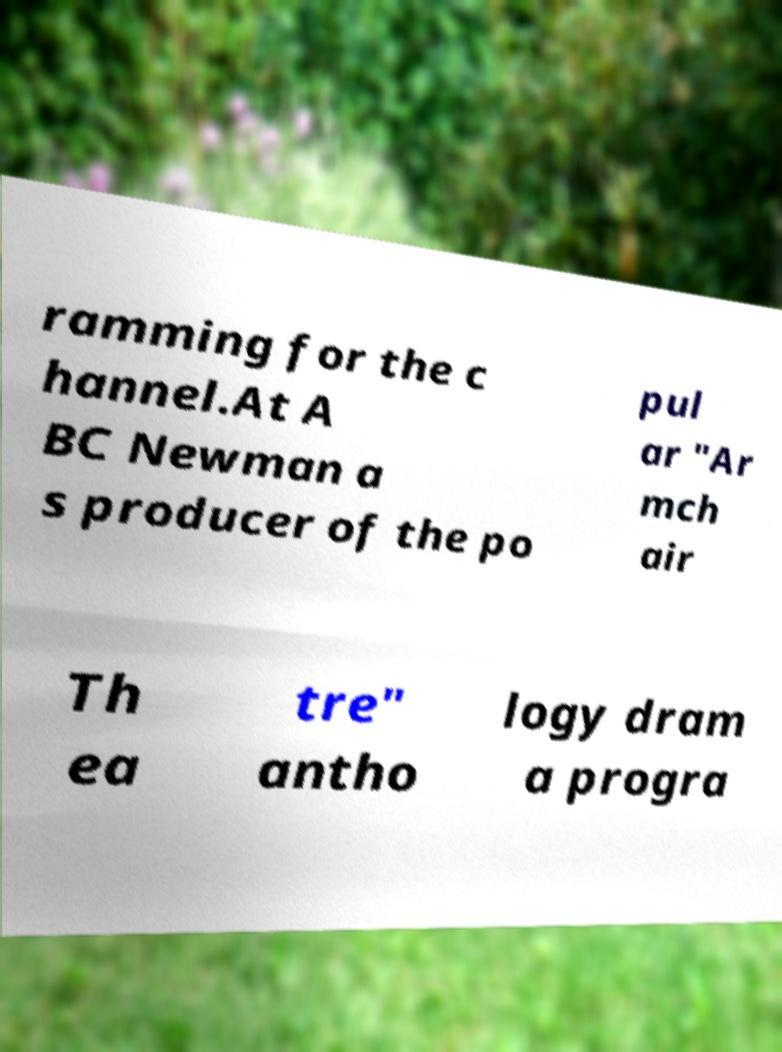Please identify and transcribe the text found in this image. ramming for the c hannel.At A BC Newman a s producer of the po pul ar "Ar mch air Th ea tre" antho logy dram a progra 